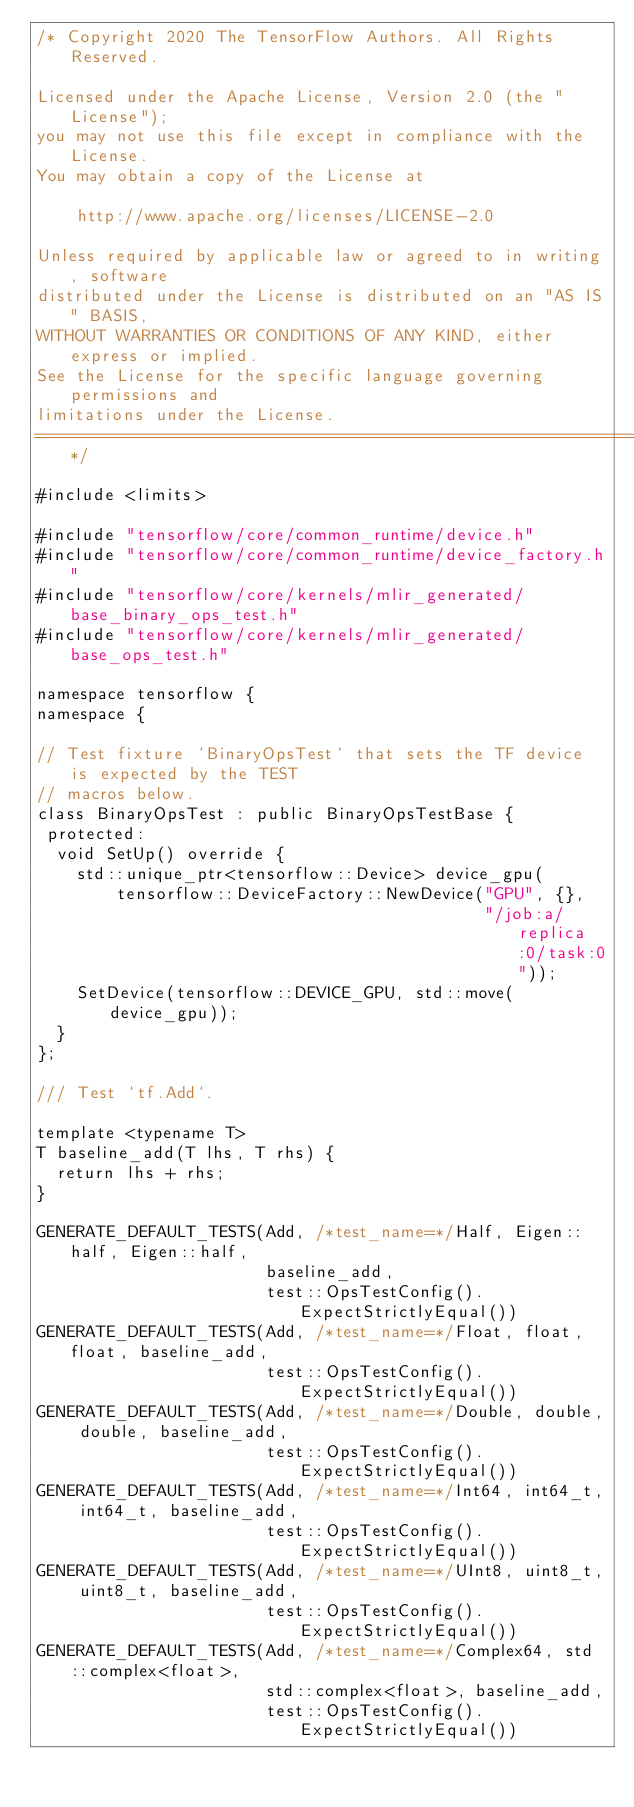<code> <loc_0><loc_0><loc_500><loc_500><_C++_>/* Copyright 2020 The TensorFlow Authors. All Rights Reserved.

Licensed under the Apache License, Version 2.0 (the "License");
you may not use this file except in compliance with the License.
You may obtain a copy of the License at

    http://www.apache.org/licenses/LICENSE-2.0

Unless required by applicable law or agreed to in writing, software
distributed under the License is distributed on an "AS IS" BASIS,
WITHOUT WARRANTIES OR CONDITIONS OF ANY KIND, either express or implied.
See the License for the specific language governing permissions and
limitations under the License.
==============================================================================*/

#include <limits>

#include "tensorflow/core/common_runtime/device.h"
#include "tensorflow/core/common_runtime/device_factory.h"
#include "tensorflow/core/kernels/mlir_generated/base_binary_ops_test.h"
#include "tensorflow/core/kernels/mlir_generated/base_ops_test.h"

namespace tensorflow {
namespace {

// Test fixture `BinaryOpsTest` that sets the TF device is expected by the TEST
// macros below.
class BinaryOpsTest : public BinaryOpsTestBase {
 protected:
  void SetUp() override {
    std::unique_ptr<tensorflow::Device> device_gpu(
        tensorflow::DeviceFactory::NewDevice("GPU", {},
                                             "/job:a/replica:0/task:0"));
    SetDevice(tensorflow::DEVICE_GPU, std::move(device_gpu));
  }
};

/// Test `tf.Add`.

template <typename T>
T baseline_add(T lhs, T rhs) {
  return lhs + rhs;
}

GENERATE_DEFAULT_TESTS(Add, /*test_name=*/Half, Eigen::half, Eigen::half,
                       baseline_add,
                       test::OpsTestConfig().ExpectStrictlyEqual())
GENERATE_DEFAULT_TESTS(Add, /*test_name=*/Float, float, float, baseline_add,
                       test::OpsTestConfig().ExpectStrictlyEqual())
GENERATE_DEFAULT_TESTS(Add, /*test_name=*/Double, double, double, baseline_add,
                       test::OpsTestConfig().ExpectStrictlyEqual())
GENERATE_DEFAULT_TESTS(Add, /*test_name=*/Int64, int64_t, int64_t, baseline_add,
                       test::OpsTestConfig().ExpectStrictlyEqual())
GENERATE_DEFAULT_TESTS(Add, /*test_name=*/UInt8, uint8_t, uint8_t, baseline_add,
                       test::OpsTestConfig().ExpectStrictlyEqual())
GENERATE_DEFAULT_TESTS(Add, /*test_name=*/Complex64, std::complex<float>,
                       std::complex<float>, baseline_add,
                       test::OpsTestConfig().ExpectStrictlyEqual())</code> 